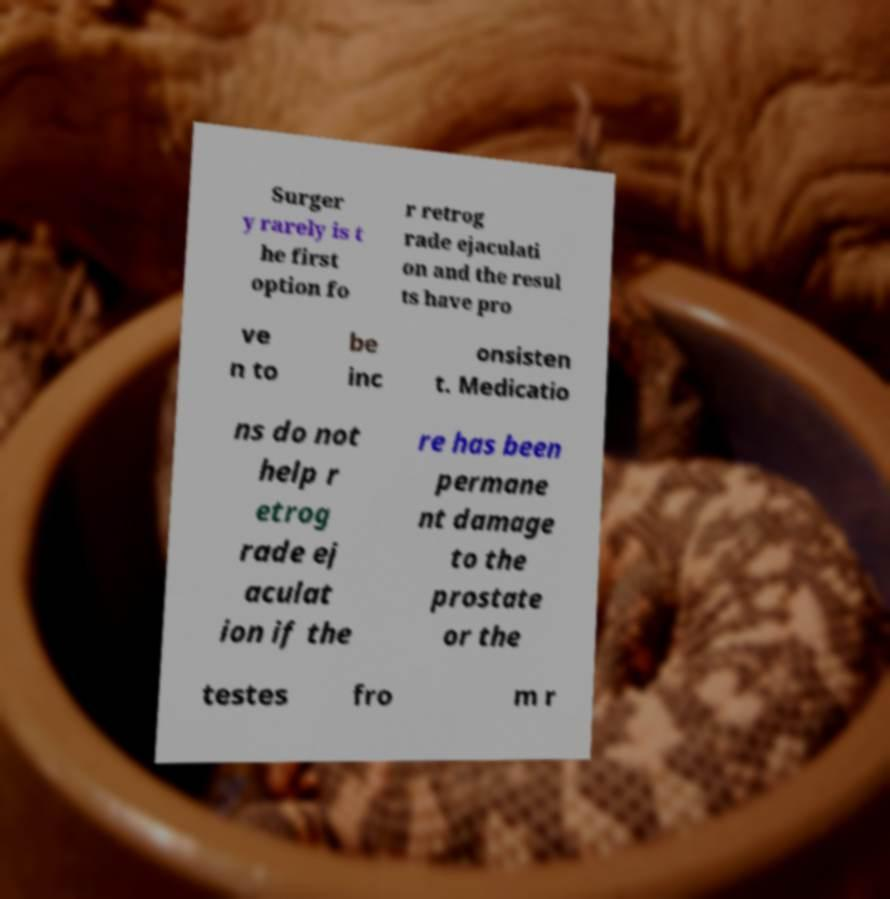Could you assist in decoding the text presented in this image and type it out clearly? Surger y rarely is t he first option fo r retrog rade ejaculati on and the resul ts have pro ve n to be inc onsisten t. Medicatio ns do not help r etrog rade ej aculat ion if the re has been permane nt damage to the prostate or the testes fro m r 